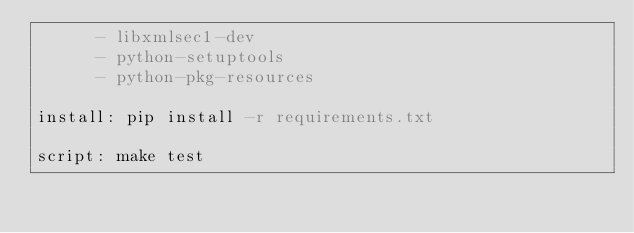<code> <loc_0><loc_0><loc_500><loc_500><_YAML_>      - libxmlsec1-dev
      - python-setuptools
      - python-pkg-resources

install: pip install -r requirements.txt

script: make test
</code> 